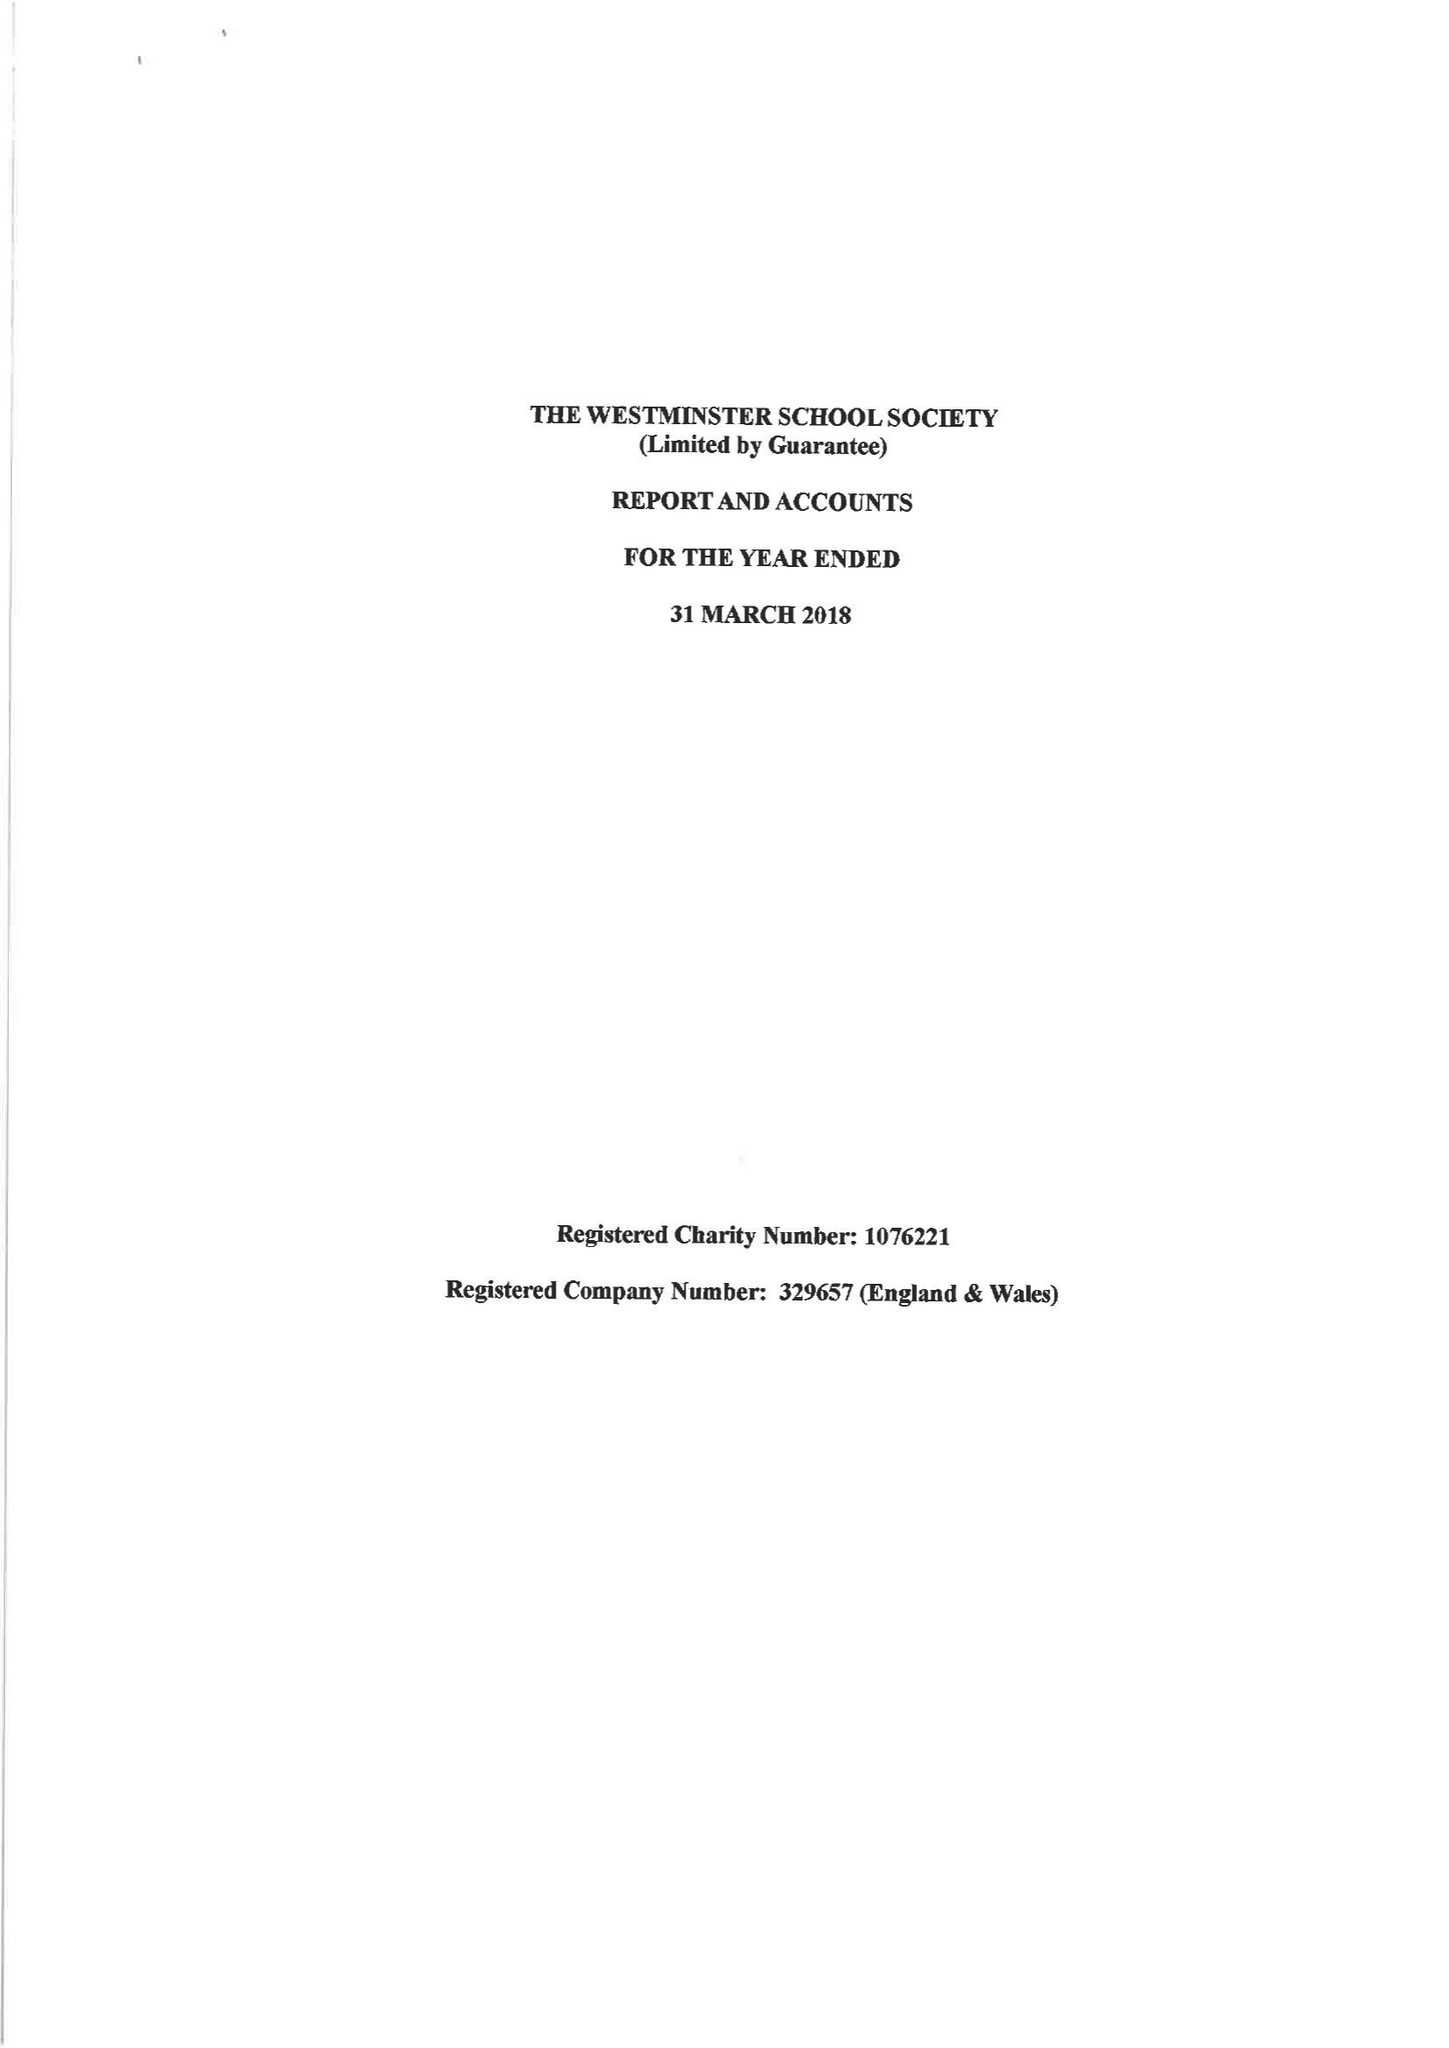What is the value for the charity_name?
Answer the question using a single word or phrase. The Westminster School Society 